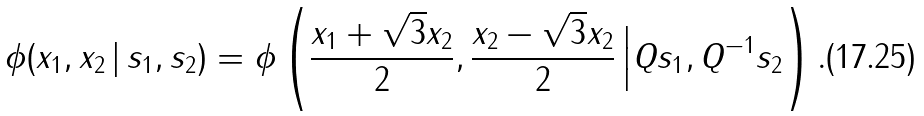<formula> <loc_0><loc_0><loc_500><loc_500>\phi ( x _ { 1 } , x _ { 2 } \, | \, s _ { 1 } , s _ { 2 } ) = \phi \left ( \frac { x _ { 1 } + \sqrt { 3 } x _ { 2 } } { 2 } , \frac { x _ { 2 } - \sqrt { 3 } x _ { 2 } } { 2 } \, \Big | Q s _ { 1 } , Q ^ { - 1 } s _ { 2 } \right ) .</formula> 